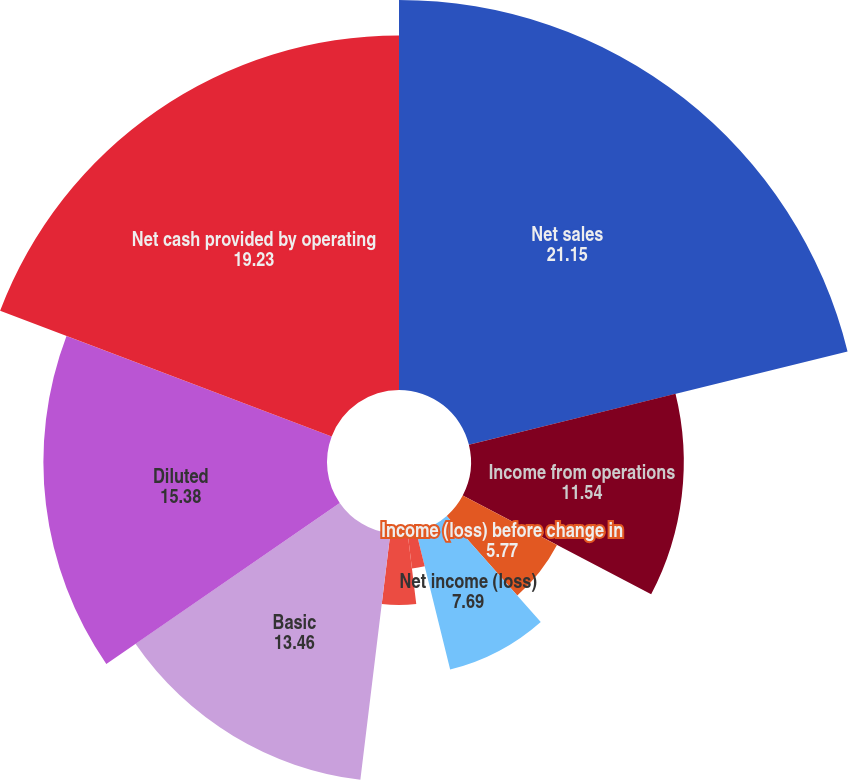Convert chart to OTSL. <chart><loc_0><loc_0><loc_500><loc_500><pie_chart><fcel>Net sales<fcel>Income from operations<fcel>Income (loss) before change in<fcel>Net income (loss)<fcel>Prior to cumulative effect of<fcel>Basic earnings (loss) per<fcel>Diluted earnings (loss) per<fcel>Basic<fcel>Diluted<fcel>Net cash provided by operating<nl><fcel>21.15%<fcel>11.54%<fcel>5.77%<fcel>7.69%<fcel>1.92%<fcel>3.85%<fcel>0.0%<fcel>13.46%<fcel>15.38%<fcel>19.23%<nl></chart> 